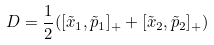Convert formula to latex. <formula><loc_0><loc_0><loc_500><loc_500>D = \frac { 1 } { 2 } ( [ \tilde { x } _ { 1 } , \tilde { p } _ { 1 } ] _ { + } + [ \tilde { x } _ { 2 } , \tilde { p } _ { 2 } ] _ { + } )</formula> 